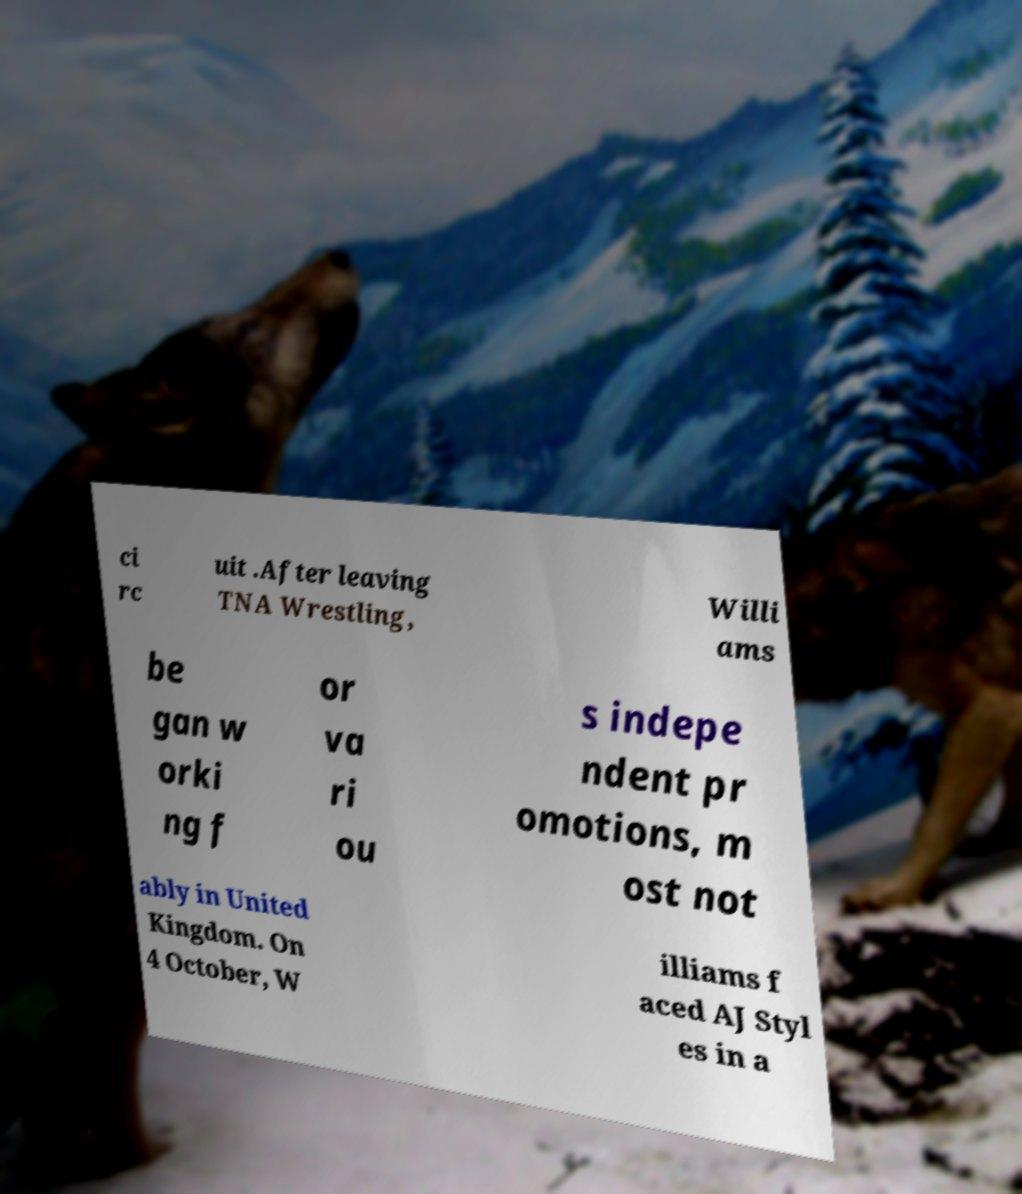Could you extract and type out the text from this image? ci rc uit .After leaving TNA Wrestling, Willi ams be gan w orki ng f or va ri ou s indepe ndent pr omotions, m ost not ably in United Kingdom. On 4 October, W illiams f aced AJ Styl es in a 